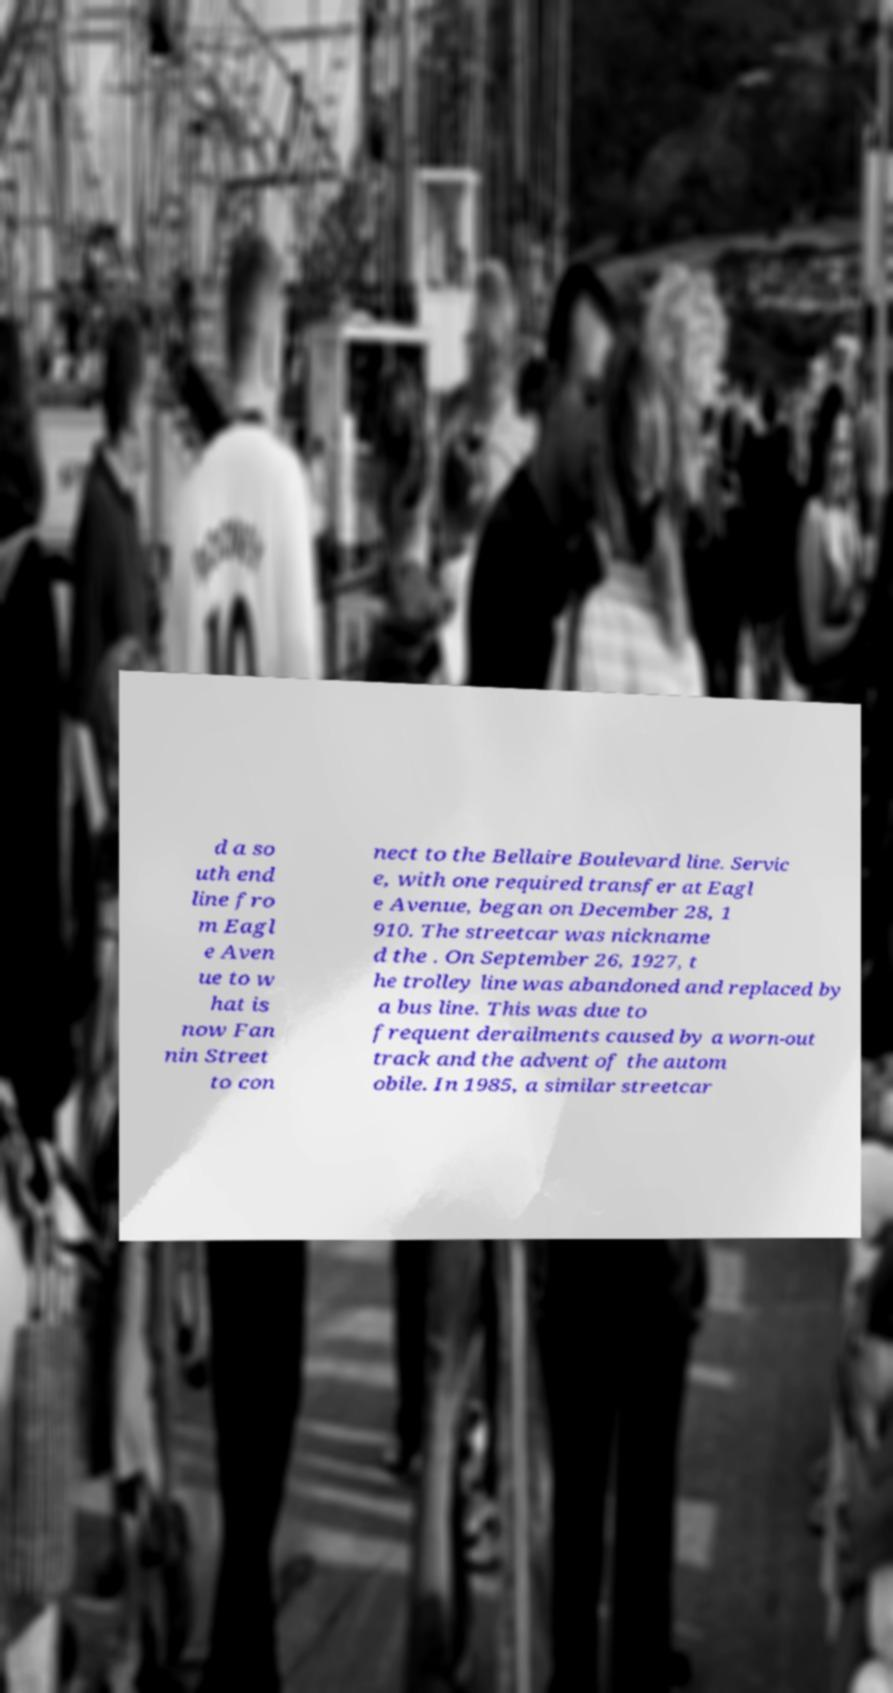Can you accurately transcribe the text from the provided image for me? d a so uth end line fro m Eagl e Aven ue to w hat is now Fan nin Street to con nect to the Bellaire Boulevard line. Servic e, with one required transfer at Eagl e Avenue, began on December 28, 1 910. The streetcar was nickname d the . On September 26, 1927, t he trolley line was abandoned and replaced by a bus line. This was due to frequent derailments caused by a worn-out track and the advent of the autom obile. In 1985, a similar streetcar 